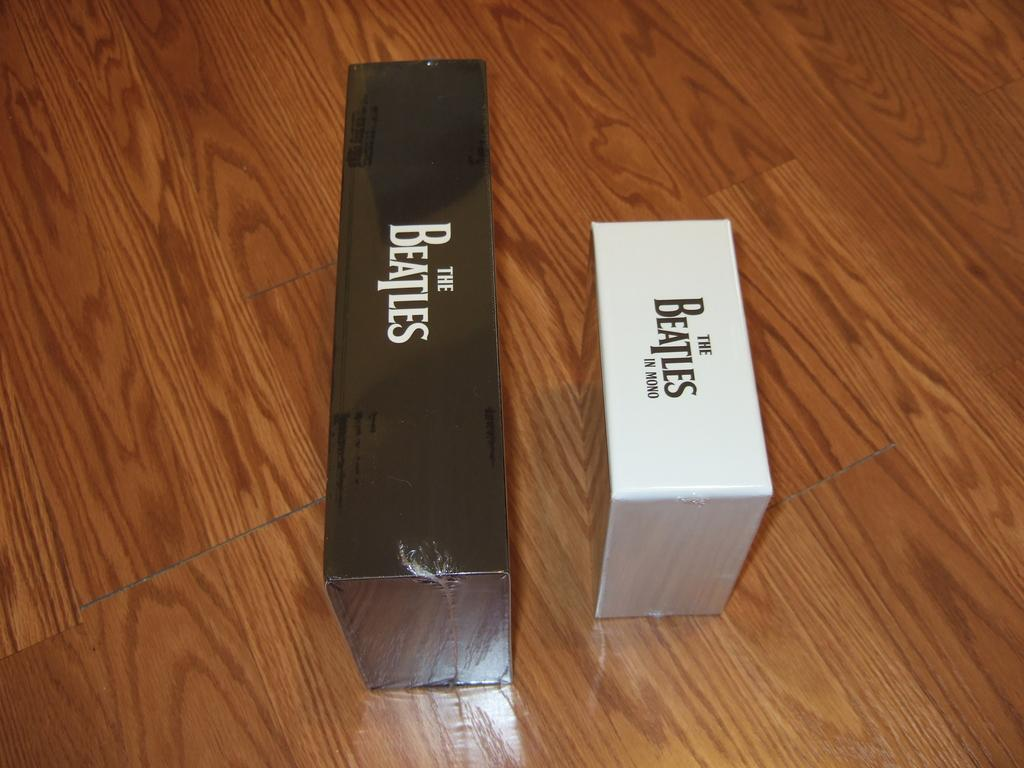Provide a one-sentence caption for the provided image. Two Beatles collections, one of which is not in stereo. 